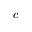<formula> <loc_0><loc_0><loc_500><loc_500>c</formula> 